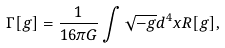Convert formula to latex. <formula><loc_0><loc_0><loc_500><loc_500>\Gamma [ g ] = { \frac { 1 } { 1 6 \pi G } } \int \sqrt { - g } d ^ { 4 } x R [ g ] ,</formula> 